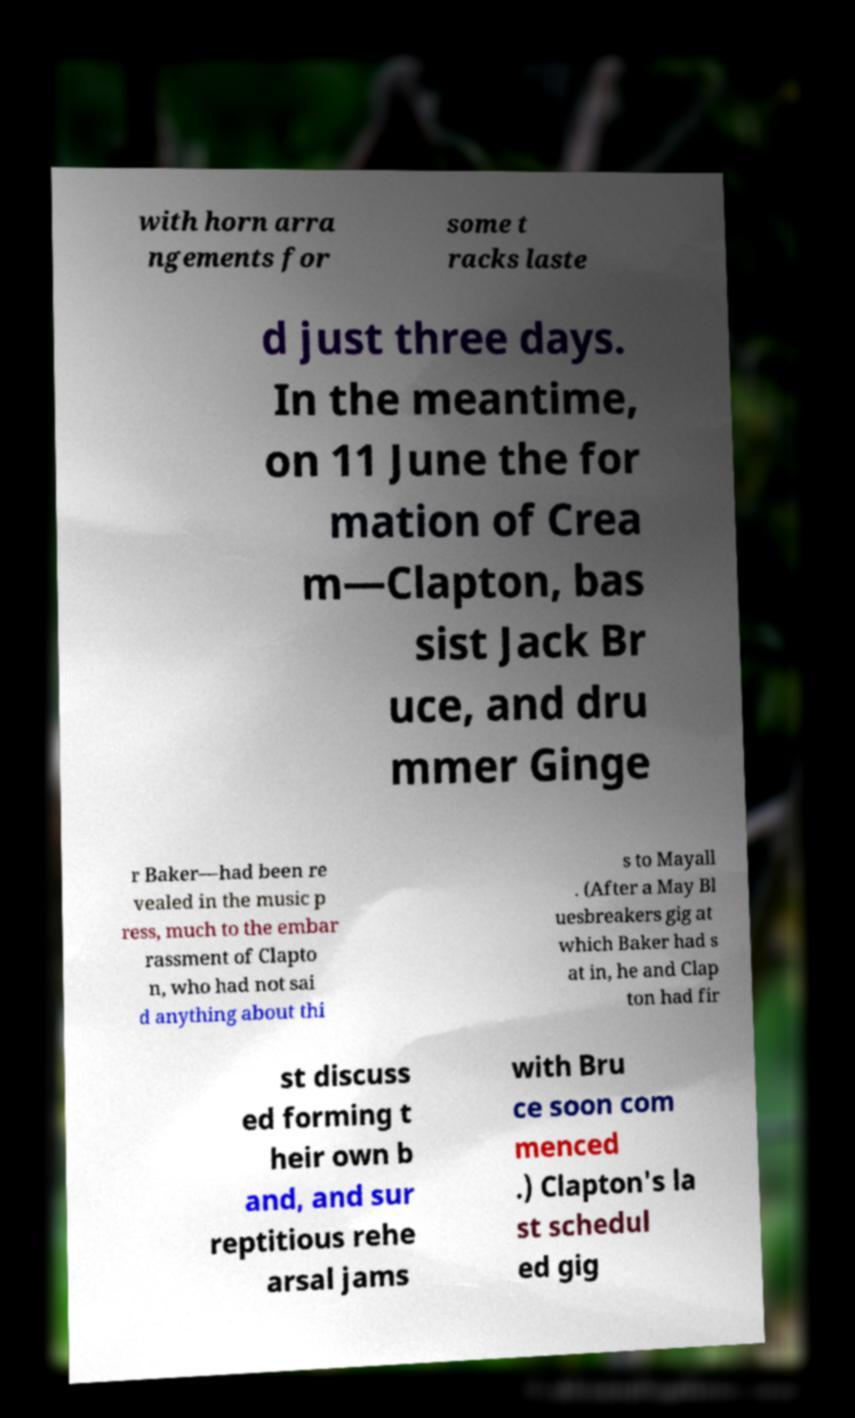Could you assist in decoding the text presented in this image and type it out clearly? with horn arra ngements for some t racks laste d just three days. In the meantime, on 11 June the for mation of Crea m—Clapton, bas sist Jack Br uce, and dru mmer Ginge r Baker—had been re vealed in the music p ress, much to the embar rassment of Clapto n, who had not sai d anything about thi s to Mayall . (After a May Bl uesbreakers gig at which Baker had s at in, he and Clap ton had fir st discuss ed forming t heir own b and, and sur reptitious rehe arsal jams with Bru ce soon com menced .) Clapton's la st schedul ed gig 